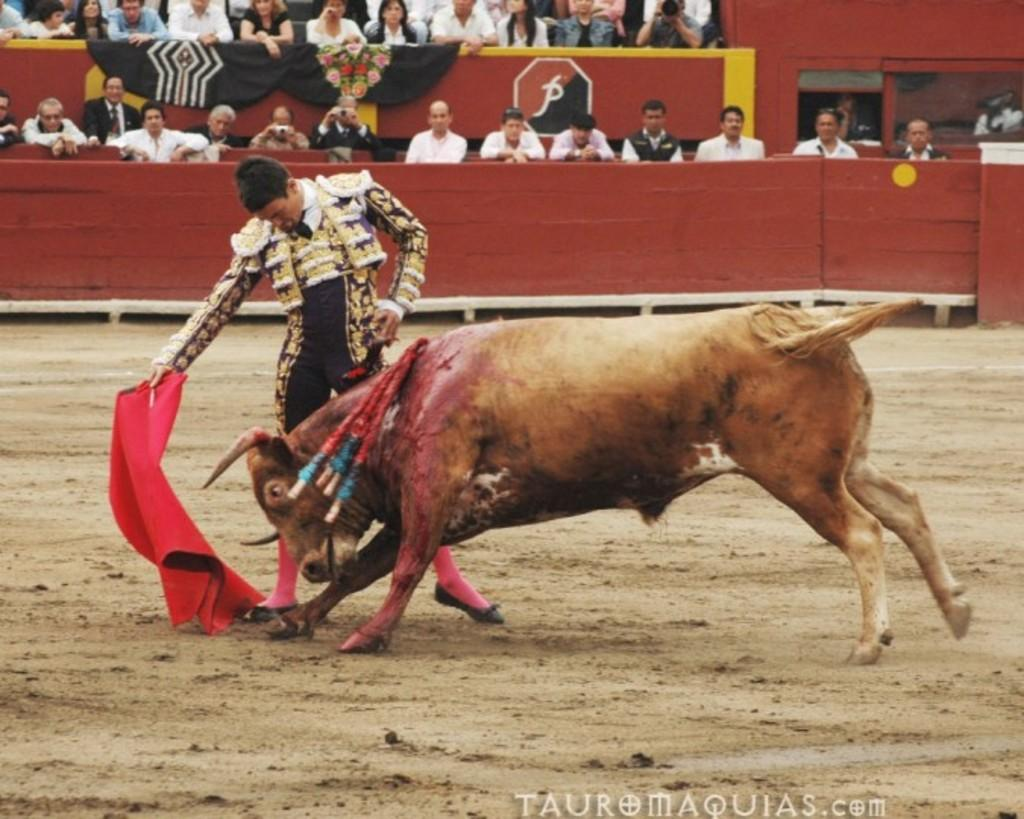What is the person in the image doing? The person is playing with a bull. Where is the person standing? The person is standing on the ground. Are there any other people in the image? Yes, there are people sitting and watching. What type of trail can be seen in the image? There is no trail present in the image. Is there a tree visible in the image? There is no tree visible in the image. 